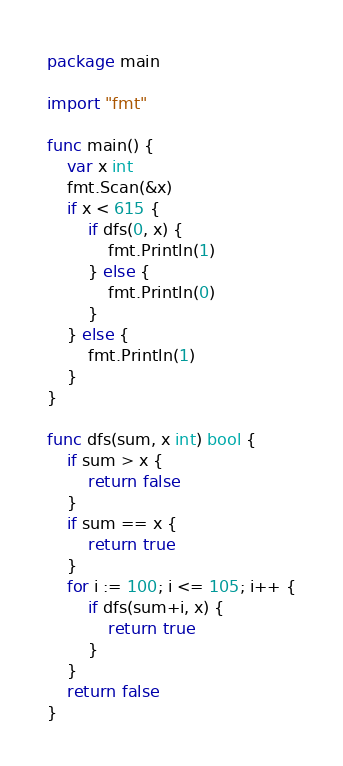<code> <loc_0><loc_0><loc_500><loc_500><_Go_>package main

import "fmt"

func main() {
	var x int
	fmt.Scan(&x)
	if x < 615 {
		if dfs(0, x) {
			fmt.Println(1)
		} else {
			fmt.Println(0)
		}
	} else {
		fmt.Println(1)
	}
}

func dfs(sum, x int) bool {
	if sum > x {
		return false
	}
	if sum == x {
		return true
	}
	for i := 100; i <= 105; i++ {
		if dfs(sum+i, x) {
			return true
		}
	}
	return false
}
</code> 